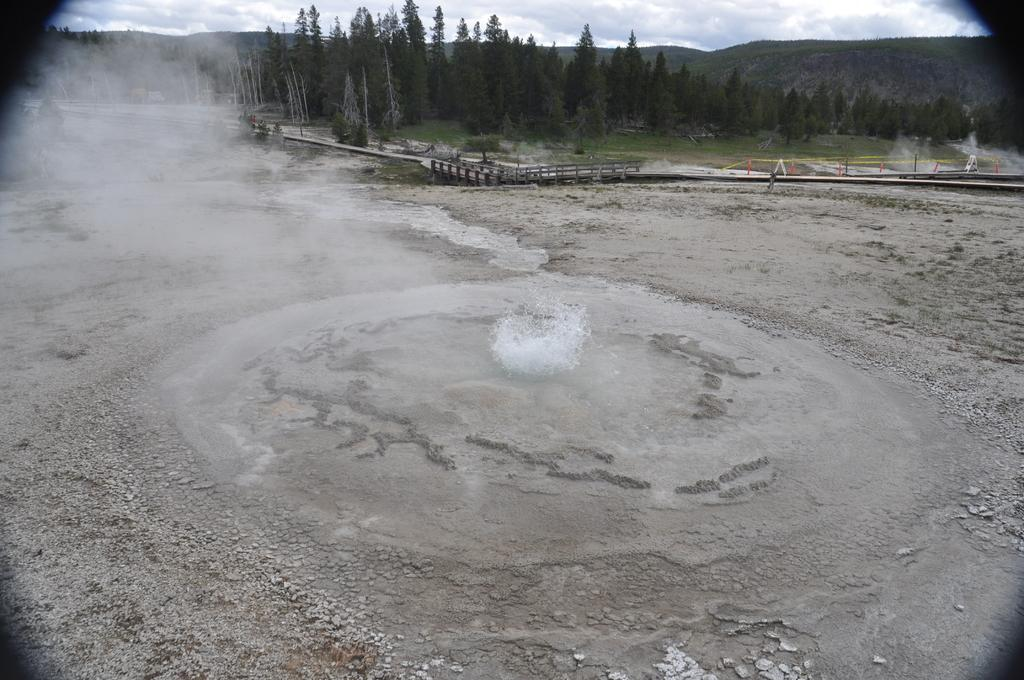What type of surface is at the bottom of the image? There is soil ground at the bottom of the image. What can be seen in the background of the image? There are trees in the background of the image. What is visible at the top of the image? The sky is visible at the top of the image. How does the soil ground expand in the image? The soil ground does not expand in the image; it is a static surface. 